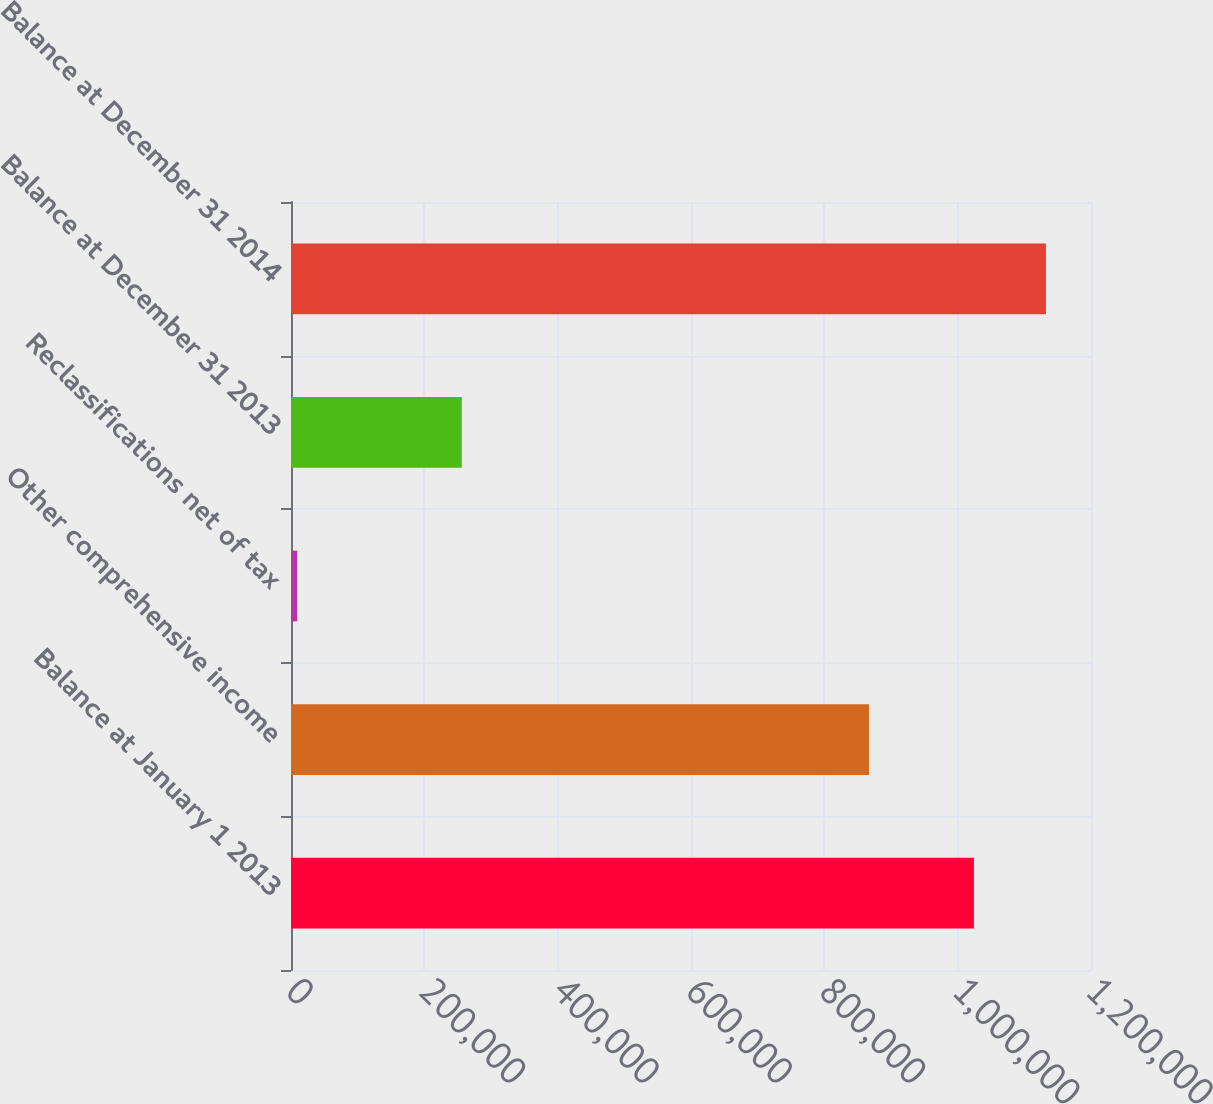Convert chart to OTSL. <chart><loc_0><loc_0><loc_500><loc_500><bar_chart><fcel>Balance at January 1 2013<fcel>Other comprehensive income<fcel>Reclassifications net of tax<fcel>Balance at December 31 2013<fcel>Balance at December 31 2014<nl><fcel>1.02437e+06<fcel>866953<fcel>9314<fcel>256196<fcel>1.13246e+06<nl></chart> 